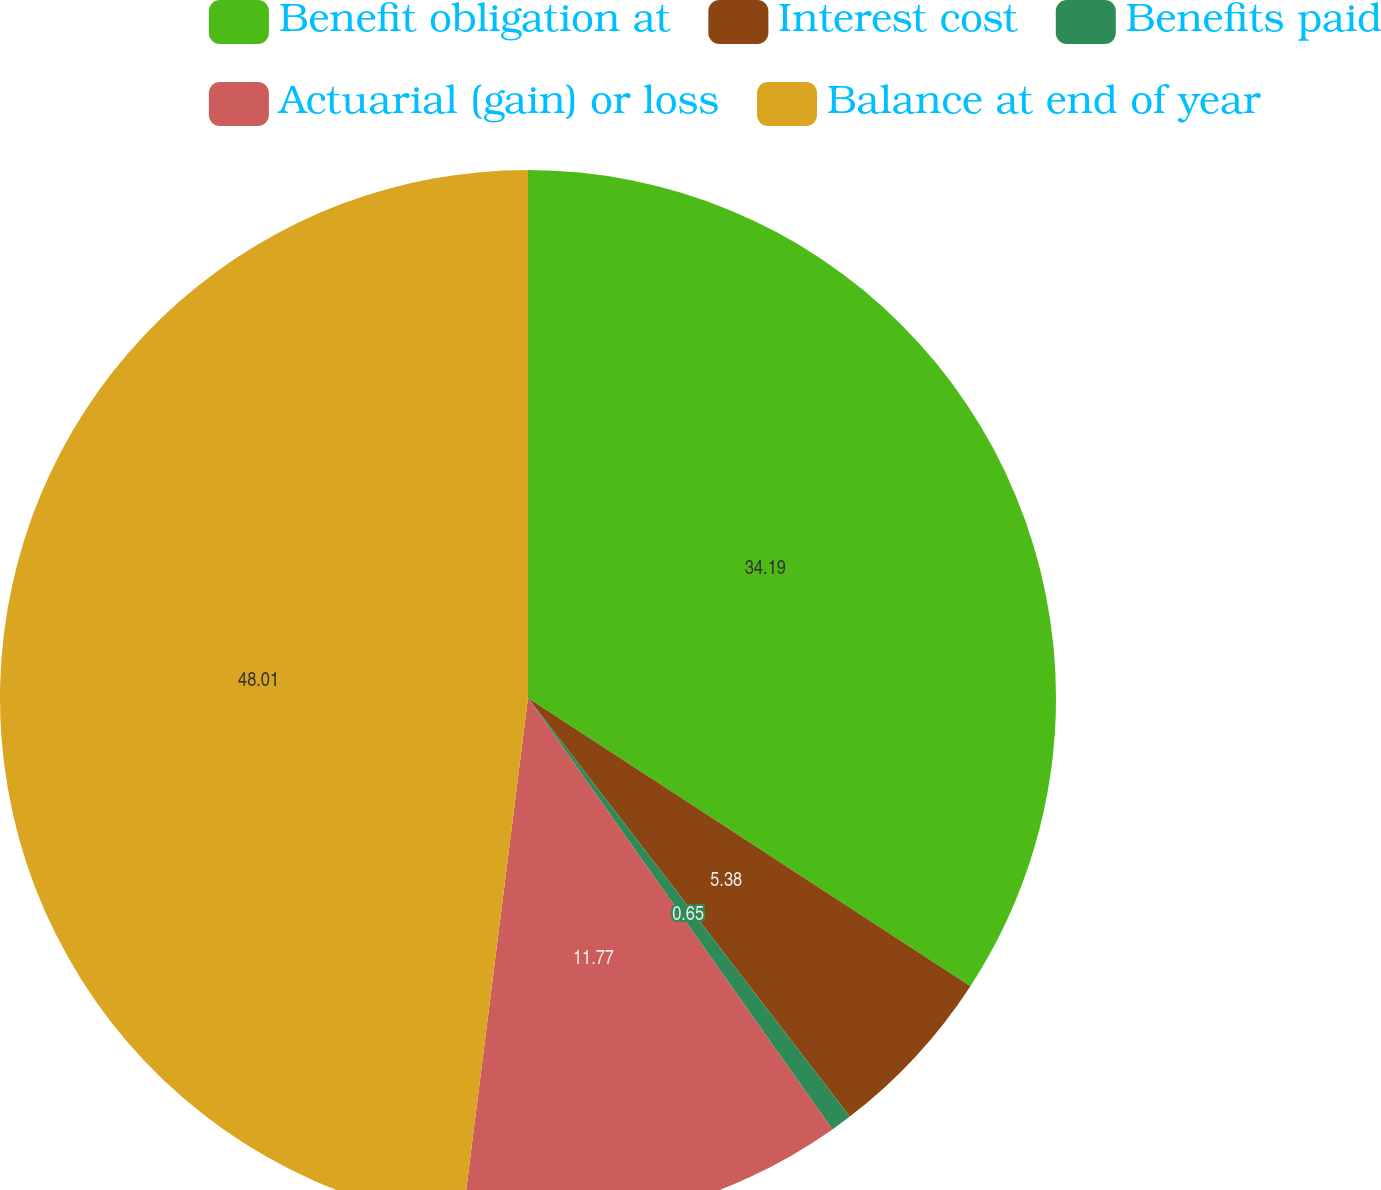Convert chart. <chart><loc_0><loc_0><loc_500><loc_500><pie_chart><fcel>Benefit obligation at<fcel>Interest cost<fcel>Benefits paid<fcel>Actuarial (gain) or loss<fcel>Balance at end of year<nl><fcel>34.19%<fcel>5.38%<fcel>0.65%<fcel>11.77%<fcel>48.01%<nl></chart> 